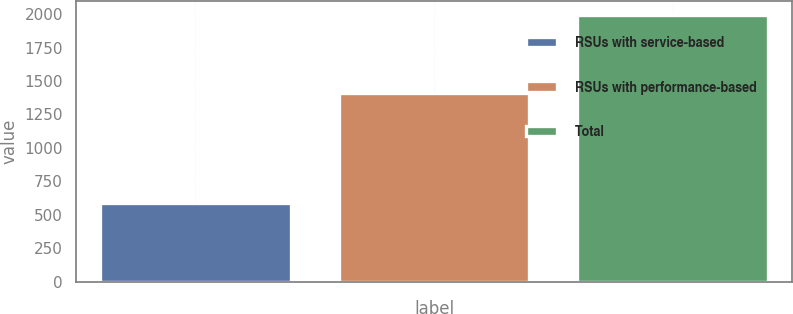Convert chart to OTSL. <chart><loc_0><loc_0><loc_500><loc_500><bar_chart><fcel>RSUs with service-based<fcel>RSUs with performance-based<fcel>Total<nl><fcel>588<fcel>1409<fcel>1997<nl></chart> 